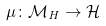Convert formula to latex. <formula><loc_0><loc_0><loc_500><loc_500>\mu \colon \mathcal { M } _ { H } \rightarrow \mathcal { H }</formula> 